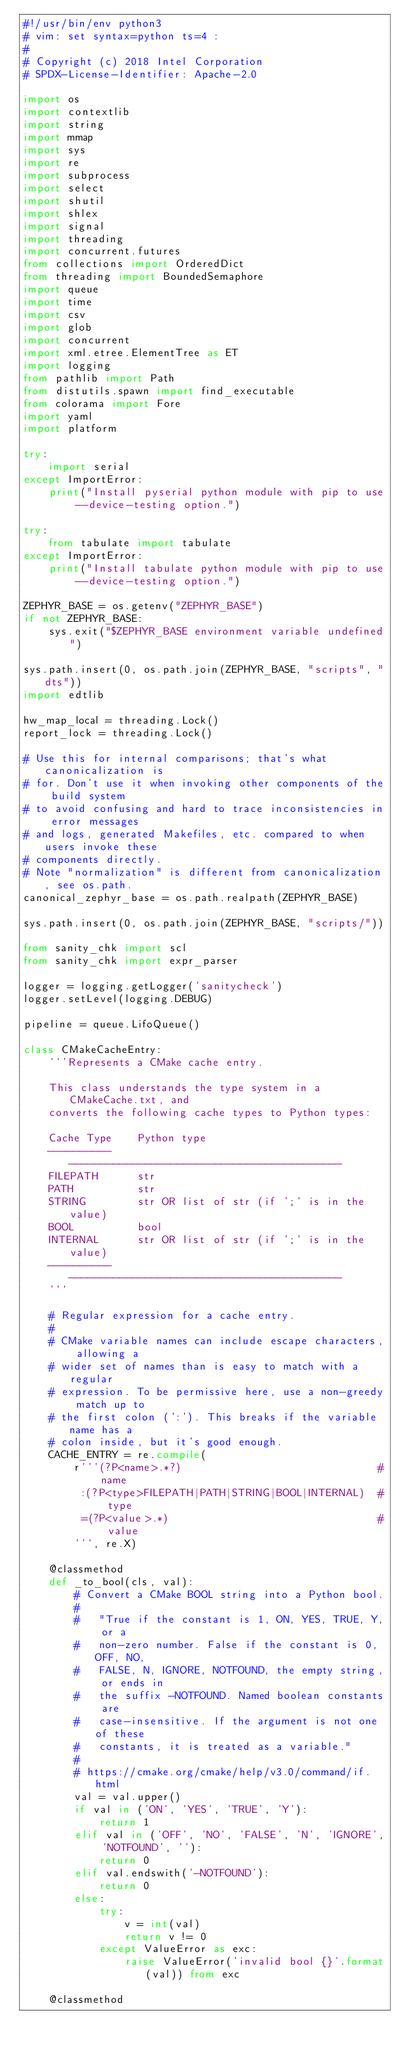<code> <loc_0><loc_0><loc_500><loc_500><_Python_>#!/usr/bin/env python3
# vim: set syntax=python ts=4 :
#
# Copyright (c) 2018 Intel Corporation
# SPDX-License-Identifier: Apache-2.0

import os
import contextlib
import string
import mmap
import sys
import re
import subprocess
import select
import shutil
import shlex
import signal
import threading
import concurrent.futures
from collections import OrderedDict
from threading import BoundedSemaphore
import queue
import time
import csv
import glob
import concurrent
import xml.etree.ElementTree as ET
import logging
from pathlib import Path
from distutils.spawn import find_executable
from colorama import Fore
import yaml
import platform

try:
    import serial
except ImportError:
    print("Install pyserial python module with pip to use --device-testing option.")

try:
    from tabulate import tabulate
except ImportError:
    print("Install tabulate python module with pip to use --device-testing option.")

ZEPHYR_BASE = os.getenv("ZEPHYR_BASE")
if not ZEPHYR_BASE:
    sys.exit("$ZEPHYR_BASE environment variable undefined")

sys.path.insert(0, os.path.join(ZEPHYR_BASE, "scripts", "dts"))
import edtlib

hw_map_local = threading.Lock()
report_lock = threading.Lock()

# Use this for internal comparisons; that's what canonicalization is
# for. Don't use it when invoking other components of the build system
# to avoid confusing and hard to trace inconsistencies in error messages
# and logs, generated Makefiles, etc. compared to when users invoke these
# components directly.
# Note "normalization" is different from canonicalization, see os.path.
canonical_zephyr_base = os.path.realpath(ZEPHYR_BASE)

sys.path.insert(0, os.path.join(ZEPHYR_BASE, "scripts/"))

from sanity_chk import scl
from sanity_chk import expr_parser

logger = logging.getLogger('sanitycheck')
logger.setLevel(logging.DEBUG)

pipeline = queue.LifoQueue()

class CMakeCacheEntry:
    '''Represents a CMake cache entry.

    This class understands the type system in a CMakeCache.txt, and
    converts the following cache types to Python types:

    Cache Type    Python type
    ----------    -------------------------------------------
    FILEPATH      str
    PATH          str
    STRING        str OR list of str (if ';' is in the value)
    BOOL          bool
    INTERNAL      str OR list of str (if ';' is in the value)
    ----------    -------------------------------------------
    '''

    # Regular expression for a cache entry.
    #
    # CMake variable names can include escape characters, allowing a
    # wider set of names than is easy to match with a regular
    # expression. To be permissive here, use a non-greedy match up to
    # the first colon (':'). This breaks if the variable name has a
    # colon inside, but it's good enough.
    CACHE_ENTRY = re.compile(
        r'''(?P<name>.*?)                               # name
         :(?P<type>FILEPATH|PATH|STRING|BOOL|INTERNAL)  # type
         =(?P<value>.*)                                 # value
        ''', re.X)

    @classmethod
    def _to_bool(cls, val):
        # Convert a CMake BOOL string into a Python bool.
        #
        #   "True if the constant is 1, ON, YES, TRUE, Y, or a
        #   non-zero number. False if the constant is 0, OFF, NO,
        #   FALSE, N, IGNORE, NOTFOUND, the empty string, or ends in
        #   the suffix -NOTFOUND. Named boolean constants are
        #   case-insensitive. If the argument is not one of these
        #   constants, it is treated as a variable."
        #
        # https://cmake.org/cmake/help/v3.0/command/if.html
        val = val.upper()
        if val in ('ON', 'YES', 'TRUE', 'Y'):
            return 1
        elif val in ('OFF', 'NO', 'FALSE', 'N', 'IGNORE', 'NOTFOUND', ''):
            return 0
        elif val.endswith('-NOTFOUND'):
            return 0
        else:
            try:
                v = int(val)
                return v != 0
            except ValueError as exc:
                raise ValueError('invalid bool {}'.format(val)) from exc

    @classmethod</code> 